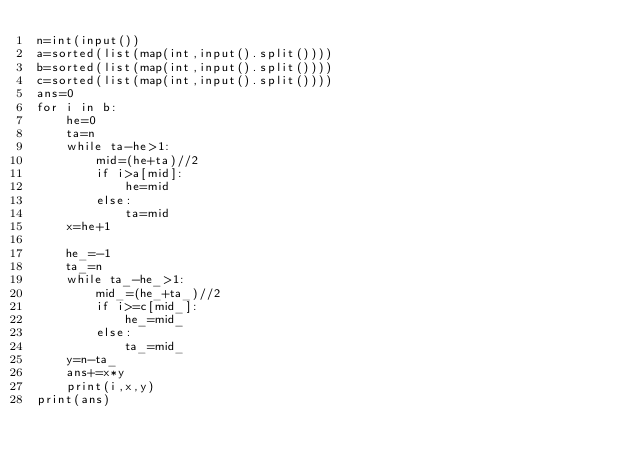<code> <loc_0><loc_0><loc_500><loc_500><_Python_>n=int(input())
a=sorted(list(map(int,input().split())))
b=sorted(list(map(int,input().split())))
c=sorted(list(map(int,input().split())))
ans=0
for i in b:
    he=0
    ta=n
    while ta-he>1:
        mid=(he+ta)//2
        if i>a[mid]:
            he=mid
        else:
            ta=mid
    x=he+1

    he_=-1
    ta_=n
    while ta_-he_>1:
        mid_=(he_+ta_)//2
        if i>=c[mid_]:
            he_=mid_
        else:
            ta_=mid_
    y=n-ta_
    ans+=x*y
    print(i,x,y)
print(ans)

</code> 